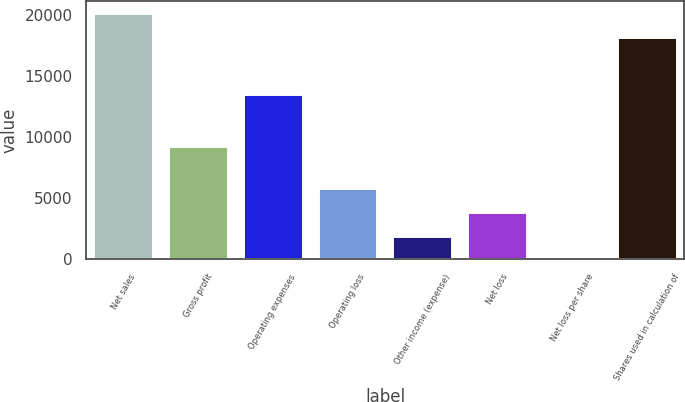<chart> <loc_0><loc_0><loc_500><loc_500><bar_chart><fcel>Net sales<fcel>Gross profit<fcel>Operating expenses<fcel>Operating loss<fcel>Other income (expense)<fcel>Net loss<fcel>Net loss per share<fcel>Shares used in calculation of<nl><fcel>20130.7<fcel>9243<fcel>13510<fcel>5816.25<fcel>1938.89<fcel>3877.57<fcel>0.21<fcel>18192<nl></chart> 